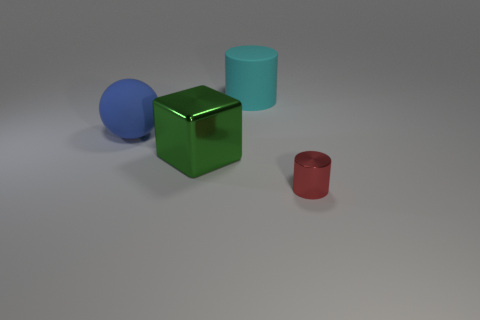Add 4 large blue spheres. How many objects exist? 8 Subtract all cubes. How many objects are left? 3 Subtract 0 brown cubes. How many objects are left? 4 Subtract all red balls. Subtract all tiny cylinders. How many objects are left? 3 Add 4 large green metallic cubes. How many large green metallic cubes are left? 5 Add 3 spheres. How many spheres exist? 4 